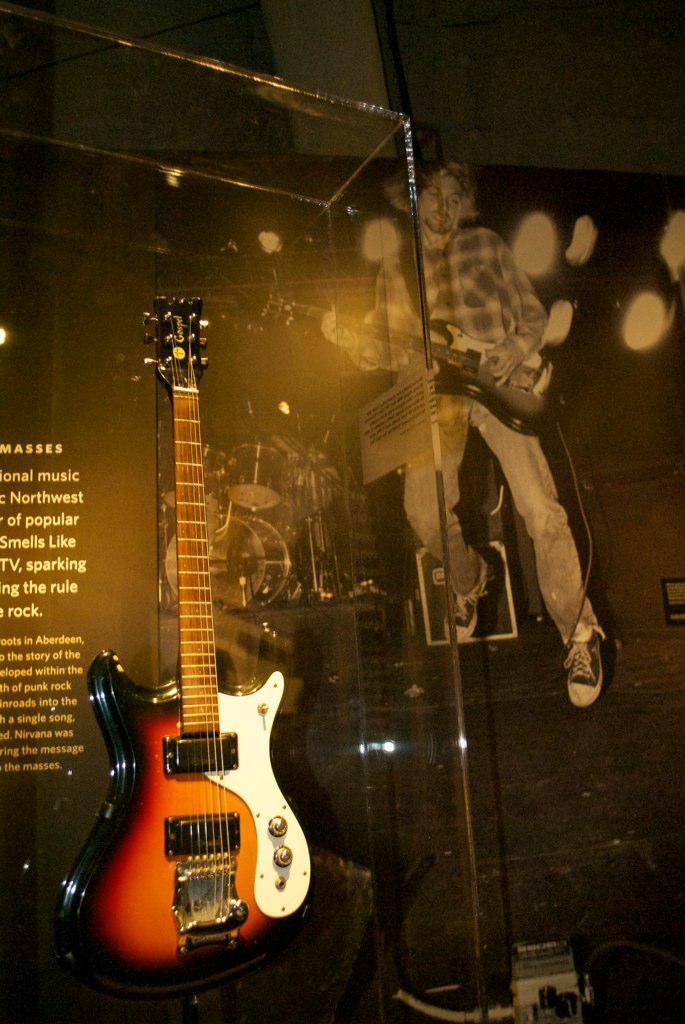In one or two sentences, can you explain what this image depicts? As we can see in the image there is a man holding guitar. On the left side there is another guitar. 